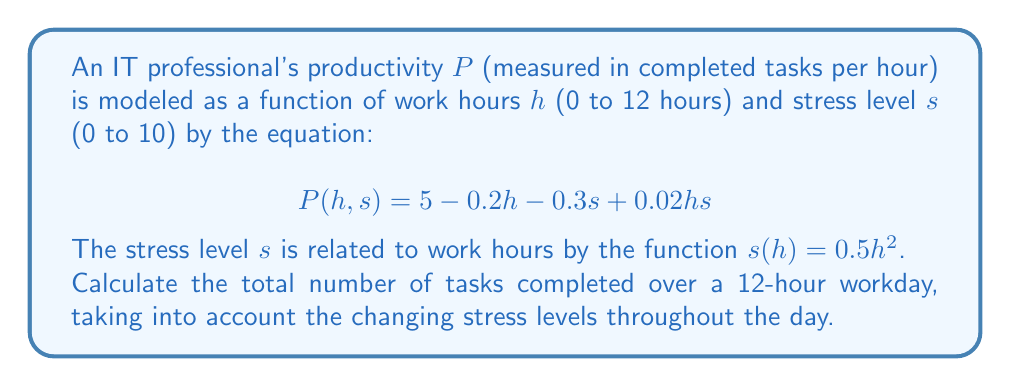Could you help me with this problem? To solve this problem, we need to use a single integral that incorporates both the productivity function and the stress level function over the 12-hour workday.

1) First, we substitute the stress function $s(h) = 0.5h^2$ into the productivity function:

   $$P(h) = 5 - 0.2h - 0.3(0.5h^2) + 0.02h(0.5h^2)$$
   $$P(h) = 5 - 0.2h - 0.15h^2 + 0.01h^3$$

2) Now, to find the total number of tasks completed, we need to integrate this function over the 12-hour period:

   $$\text{Total Tasks} = \int_0^{12} P(h) \, dh$$

3) Let's expand this integral:

   $$\int_0^{12} (5 - 0.2h - 0.15h^2 + 0.01h^3) \, dh$$

4) Integrate each term:

   $$\left[5h - 0.1h^2 - 0.05h^3 + 0.0025h^4\right]_0^{12}$$

5) Evaluate at the limits:

   $$(60 - 14.4 - 86.4 + 51.84) - (0 - 0 - 0 + 0)$$

6) Calculate the final result:

   $$11.04$$

Thus, the total number of tasks completed over the 12-hour workday is approximately 11.04.
Answer: 11.04 tasks 